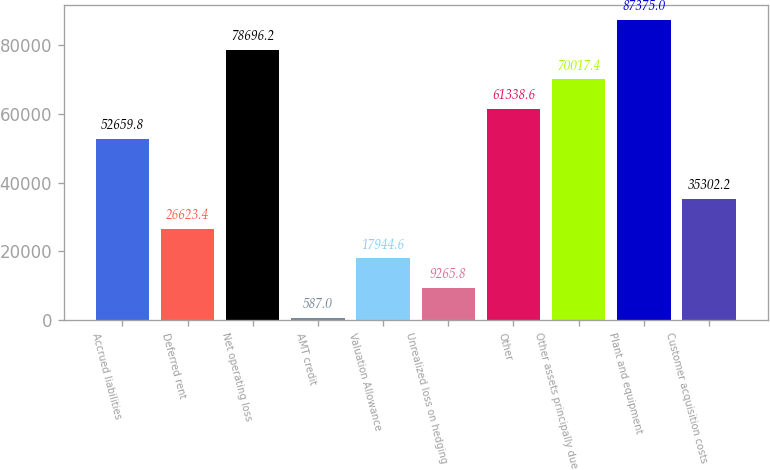<chart> <loc_0><loc_0><loc_500><loc_500><bar_chart><fcel>Accrued liabilities<fcel>Deferred rent<fcel>Net operating loss<fcel>AMT credit<fcel>Valuation Allowance<fcel>Unrealized loss on hedging<fcel>Other<fcel>Other assets principally due<fcel>Plant and equipment<fcel>Customer acquisition costs<nl><fcel>52659.8<fcel>26623.4<fcel>78696.2<fcel>587<fcel>17944.6<fcel>9265.8<fcel>61338.6<fcel>70017.4<fcel>87375<fcel>35302.2<nl></chart> 